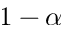<formula> <loc_0><loc_0><loc_500><loc_500>1 - \alpha</formula> 